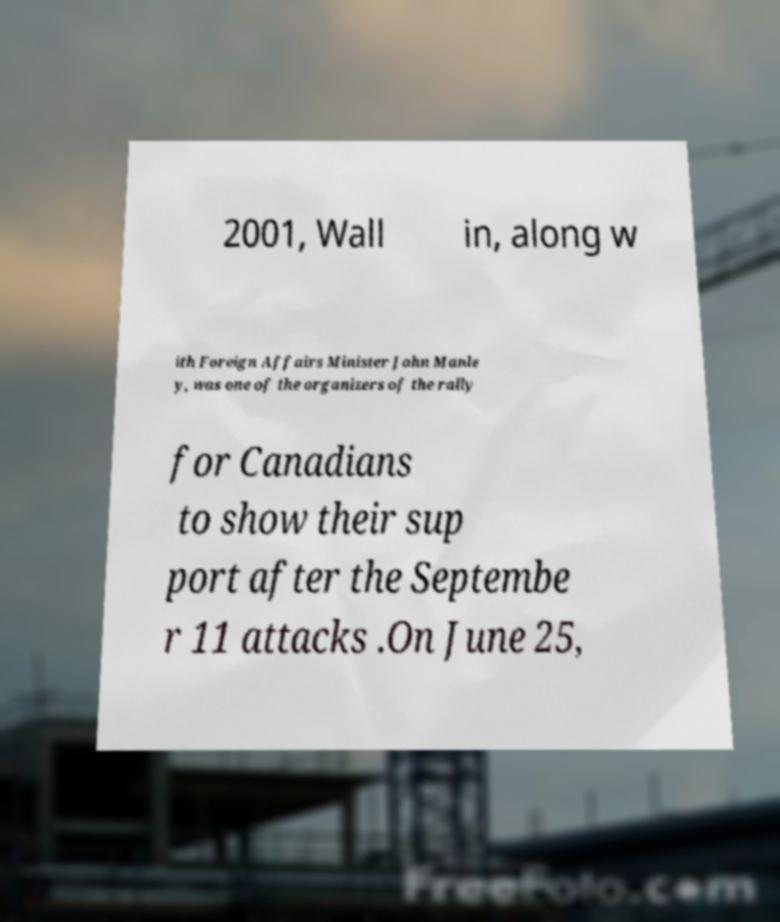There's text embedded in this image that I need extracted. Can you transcribe it verbatim? 2001, Wall in, along w ith Foreign Affairs Minister John Manle y, was one of the organizers of the rally for Canadians to show their sup port after the Septembe r 11 attacks .On June 25, 